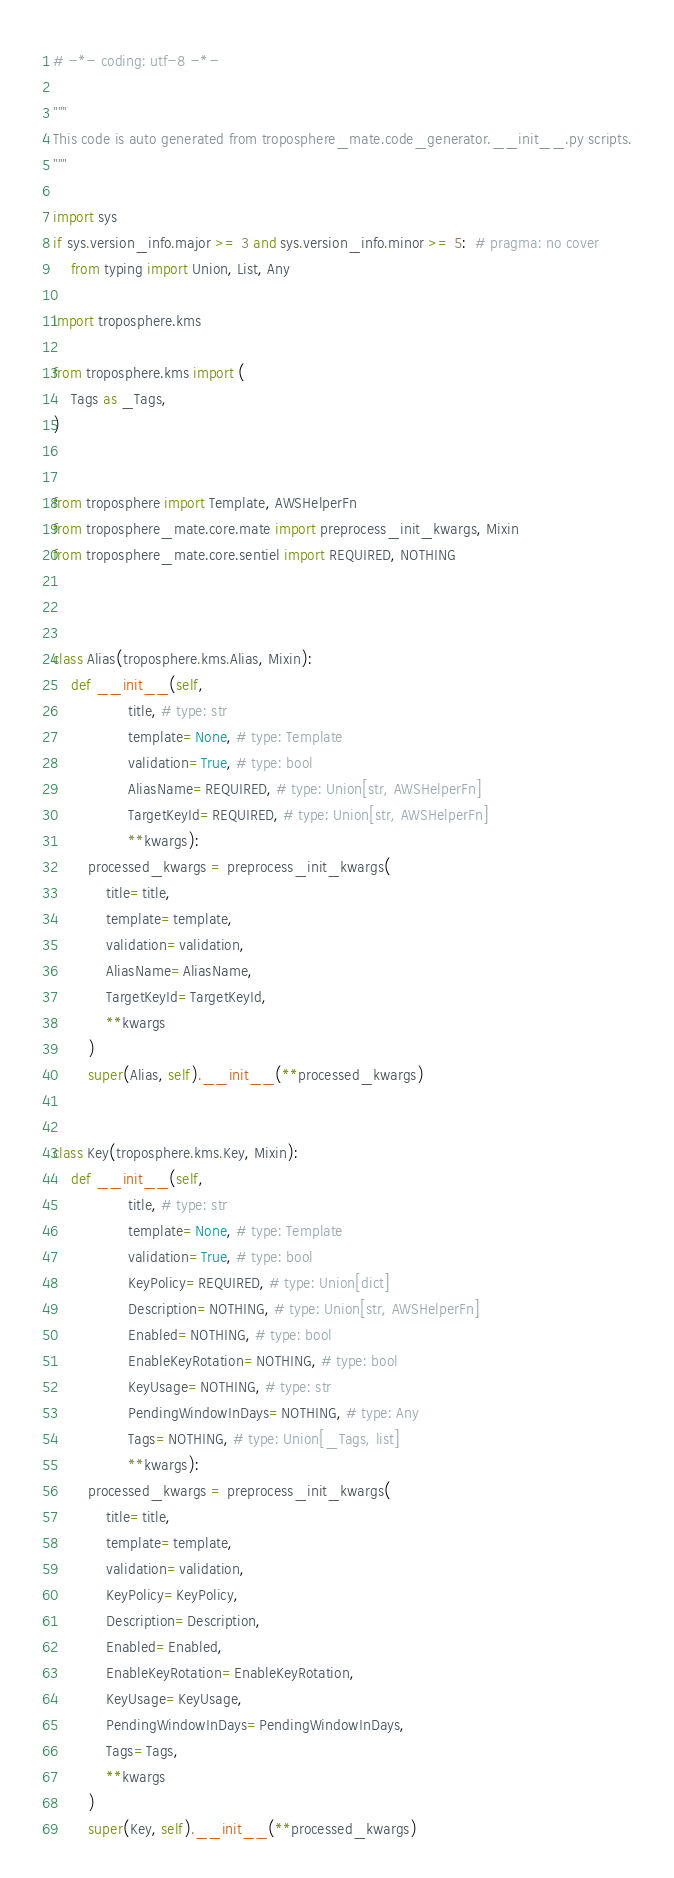Convert code to text. <code><loc_0><loc_0><loc_500><loc_500><_Python_># -*- coding: utf-8 -*-

"""
This code is auto generated from troposphere_mate.code_generator.__init__.py scripts.
"""

import sys
if sys.version_info.major >= 3 and sys.version_info.minor >= 5:  # pragma: no cover
    from typing import Union, List, Any

import troposphere.kms

from troposphere.kms import (
    Tags as _Tags,
)


from troposphere import Template, AWSHelperFn
from troposphere_mate.core.mate import preprocess_init_kwargs, Mixin
from troposphere_mate.core.sentiel import REQUIRED, NOTHING



class Alias(troposphere.kms.Alias, Mixin):
    def __init__(self,
                 title, # type: str
                 template=None, # type: Template
                 validation=True, # type: bool
                 AliasName=REQUIRED, # type: Union[str, AWSHelperFn]
                 TargetKeyId=REQUIRED, # type: Union[str, AWSHelperFn]
                 **kwargs):
        processed_kwargs = preprocess_init_kwargs(
            title=title,
            template=template,
            validation=validation,
            AliasName=AliasName,
            TargetKeyId=TargetKeyId,
            **kwargs
        )
        super(Alias, self).__init__(**processed_kwargs)


class Key(troposphere.kms.Key, Mixin):
    def __init__(self,
                 title, # type: str
                 template=None, # type: Template
                 validation=True, # type: bool
                 KeyPolicy=REQUIRED, # type: Union[dict]
                 Description=NOTHING, # type: Union[str, AWSHelperFn]
                 Enabled=NOTHING, # type: bool
                 EnableKeyRotation=NOTHING, # type: bool
                 KeyUsage=NOTHING, # type: str
                 PendingWindowInDays=NOTHING, # type: Any
                 Tags=NOTHING, # type: Union[_Tags, list]
                 **kwargs):
        processed_kwargs = preprocess_init_kwargs(
            title=title,
            template=template,
            validation=validation,
            KeyPolicy=KeyPolicy,
            Description=Description,
            Enabled=Enabled,
            EnableKeyRotation=EnableKeyRotation,
            KeyUsage=KeyUsage,
            PendingWindowInDays=PendingWindowInDays,
            Tags=Tags,
            **kwargs
        )
        super(Key, self).__init__(**processed_kwargs)
</code> 